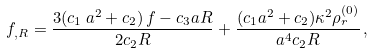<formula> <loc_0><loc_0><loc_500><loc_500>f _ { , R } = \frac { 3 ( c _ { 1 } \, a ^ { 2 } + c _ { 2 } ) \, f - c _ { 3 } a R } { 2 c _ { 2 } R } + \frac { ( c _ { 1 } a ^ { 2 } + c _ { 2 } ) \kappa ^ { 2 } \rho _ { r } ^ { ( 0 ) } } { a ^ { 4 } c _ { 2 } R } \, ,</formula> 